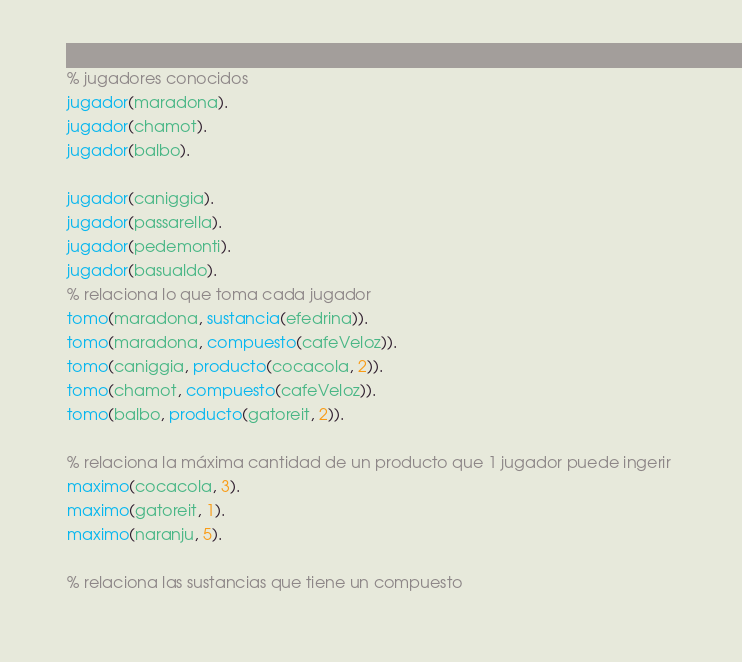Convert code to text. <code><loc_0><loc_0><loc_500><loc_500><_Prolog_>% jugadores conocidos 
jugador(maradona). 
jugador(chamot). 
jugador(balbo). 
 
jugador(caniggia). 
jugador(passarella). 
jugador(pedemonti). 
jugador(basualdo). 
% relaciona lo que toma cada jugador 
tomo(maradona, sustancia(efedrina)). 
tomo(maradona, compuesto(cafeVeloz)). 
tomo(caniggia, producto(cocacola, 2)). 
tomo(chamot, compuesto(cafeVeloz)). 
tomo(balbo, producto(gatoreit, 2)). 

% relaciona la máxima cantidad de un producto que 1 jugador puede ingerir 
maximo(cocacola, 3). 
maximo(gatoreit, 1). 
maximo(naranju, 5). 
 
% relaciona las sustancias que tiene un compuesto </code> 